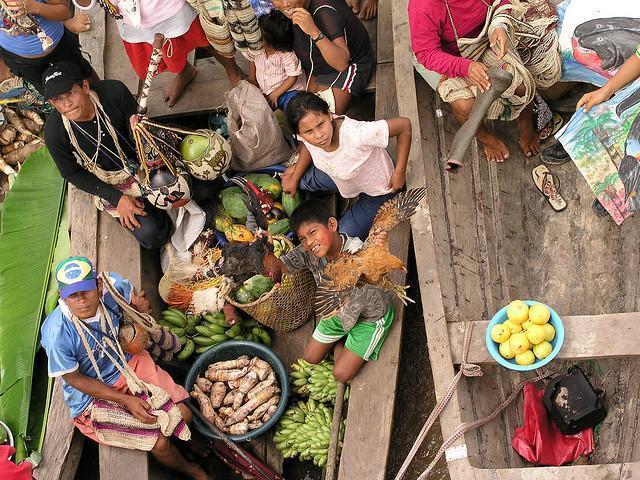Where are the persons here headed?
Select the accurate response from the four choices given to answer the question.
Options: Casinos, bathrooms, villas, market. Market. 